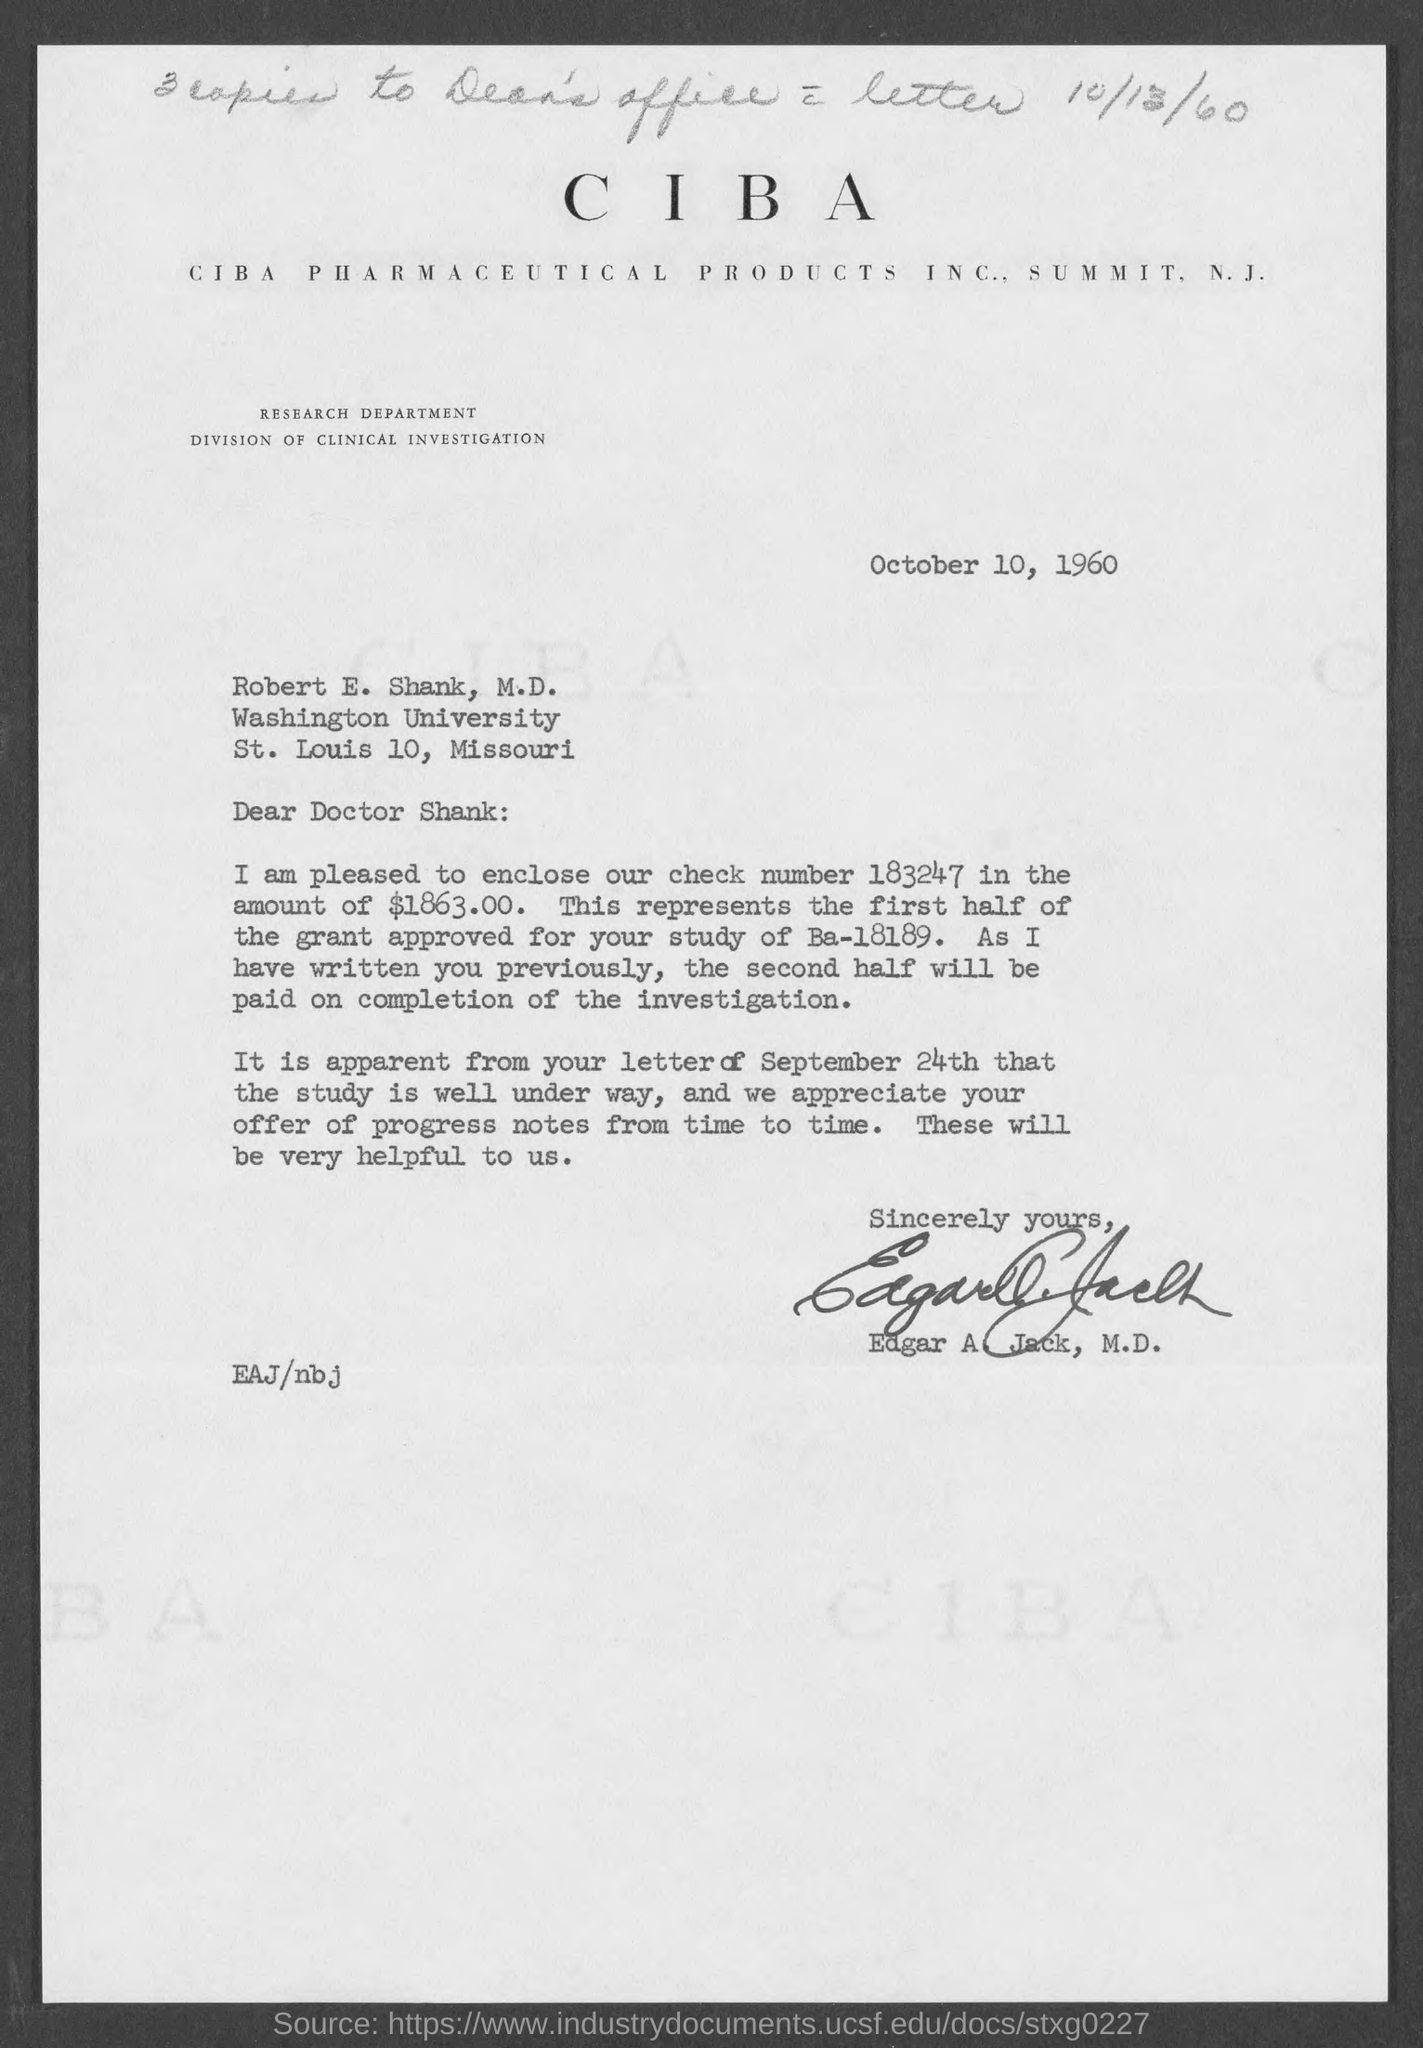Identify some key points in this picture. The letter is addressed to Robert E. Shank, M.D. The check number is 183247 and the amount is $1863.00. The number of copies that need to be sent to the Dean's Office is 3. The document is dated October 10, 1960. The letter has been signed by Edgar A. Jack, M.D. 